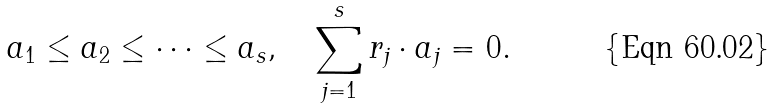<formula> <loc_0><loc_0><loc_500><loc_500>a _ { 1 } \leq a _ { 2 } \leq \cdots \leq a _ { s } , \quad \sum _ { j = 1 } ^ { s } r _ { j } \cdot a _ { j } = 0 .</formula> 